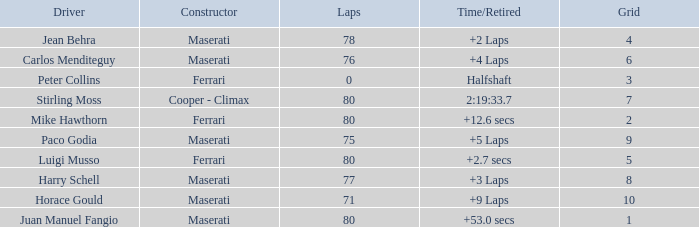What's the average Grid for a Maserati with less than 80 laps, and a Time/Retired of +2 laps? 4.0. 